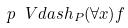Convert formula to latex. <formula><loc_0><loc_0><loc_500><loc_500>p \ V d a s h _ { P } ( \forall x ) f</formula> 